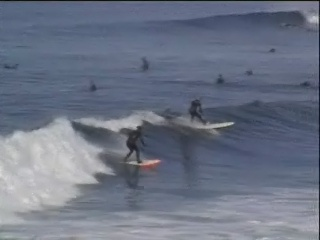Describe the objects in this image and their specific colors. I can see people in black and gray tones, surfboard in black, darkgray, and gray tones, people in black and gray tones, surfboard in black, darkgray, gray, and brown tones, and people in black, gray, and darkblue tones in this image. 